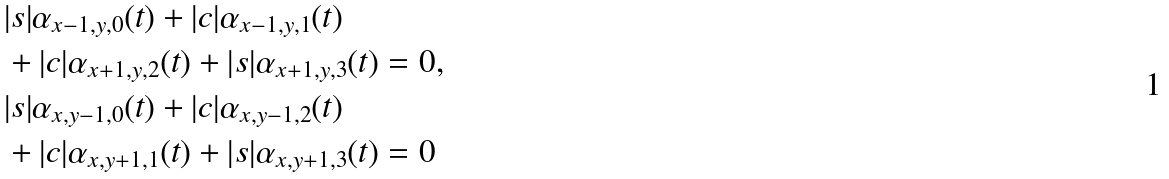Convert formula to latex. <formula><loc_0><loc_0><loc_500><loc_500>& | s | \alpha _ { x - 1 , y , 0 } ( t ) + | c | \alpha _ { x - 1 , y , 1 } ( t ) \\ & + | c | \alpha _ { x + 1 , y , 2 } ( t ) + | s | \alpha _ { x + 1 , y , 3 } ( t ) = 0 , \\ & | s | \alpha _ { x , y - 1 , 0 } ( t ) + | c | \alpha _ { x , y - 1 , 2 } ( t ) \\ & + | c | \alpha _ { x , y + 1 , 1 } ( t ) + | s | \alpha _ { x , y + 1 , 3 } ( t ) = 0</formula> 